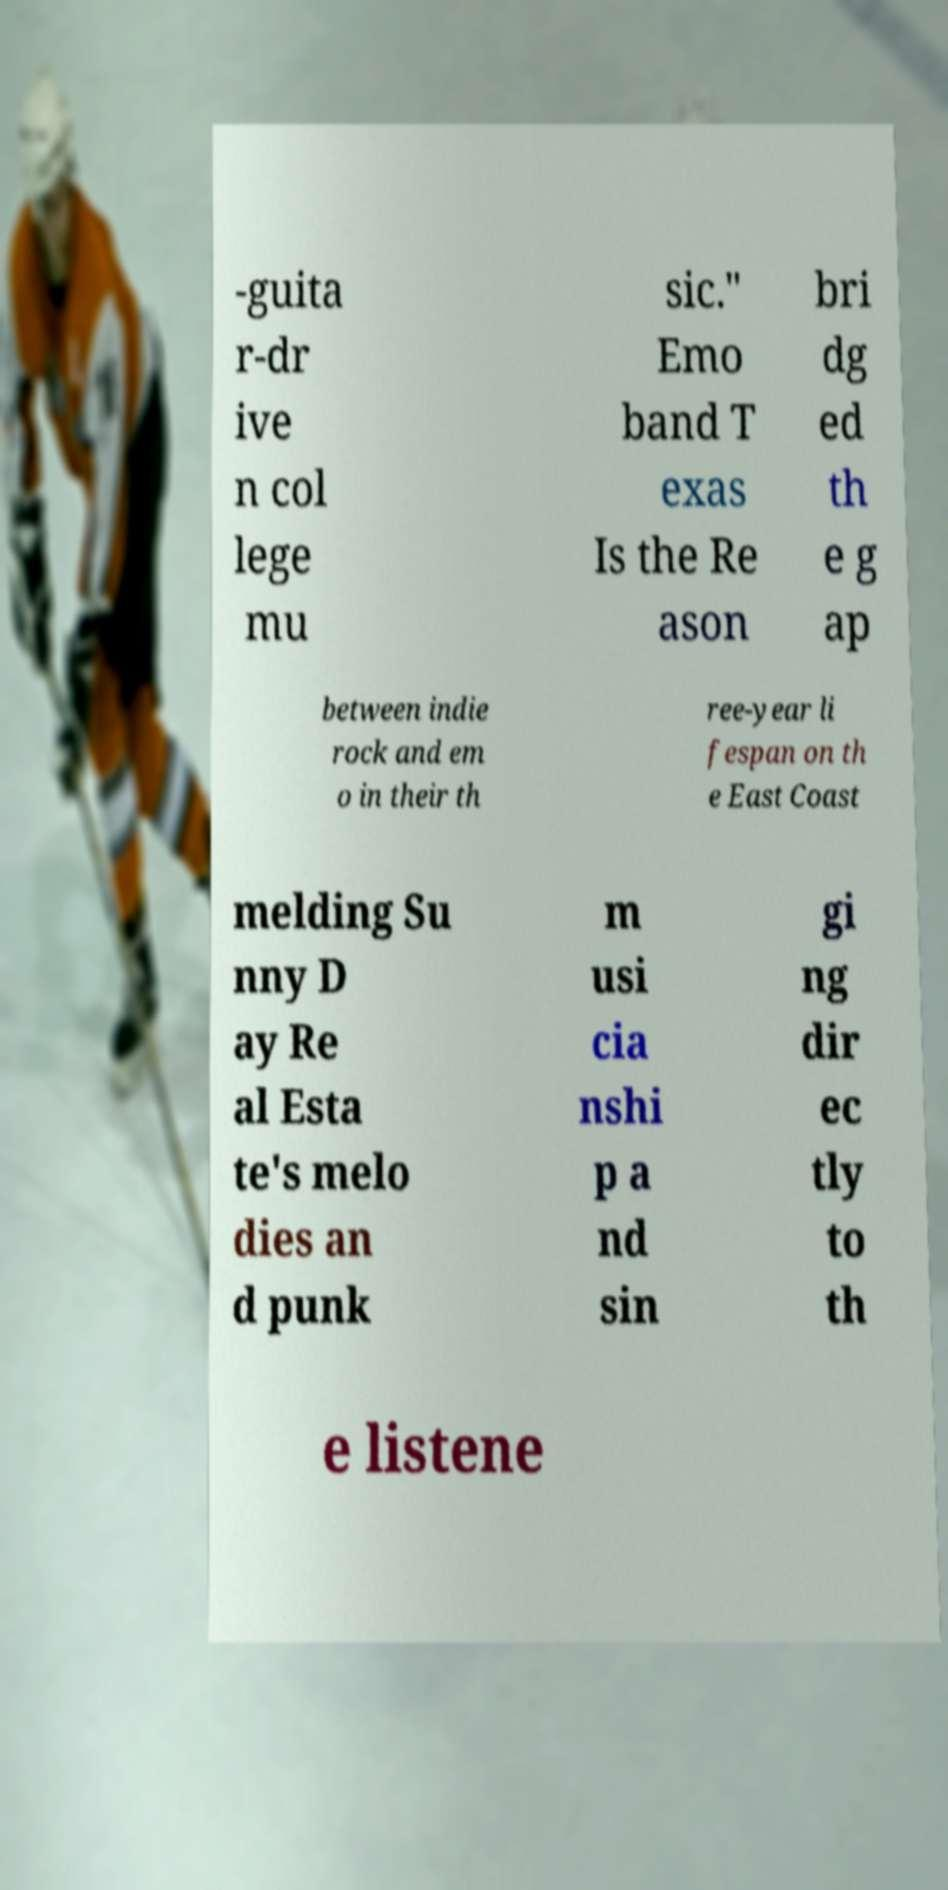Can you accurately transcribe the text from the provided image for me? -guita r-dr ive n col lege mu sic." Emo band T exas Is the Re ason bri dg ed th e g ap between indie rock and em o in their th ree-year li fespan on th e East Coast melding Su nny D ay Re al Esta te's melo dies an d punk m usi cia nshi p a nd sin gi ng dir ec tly to th e listene 